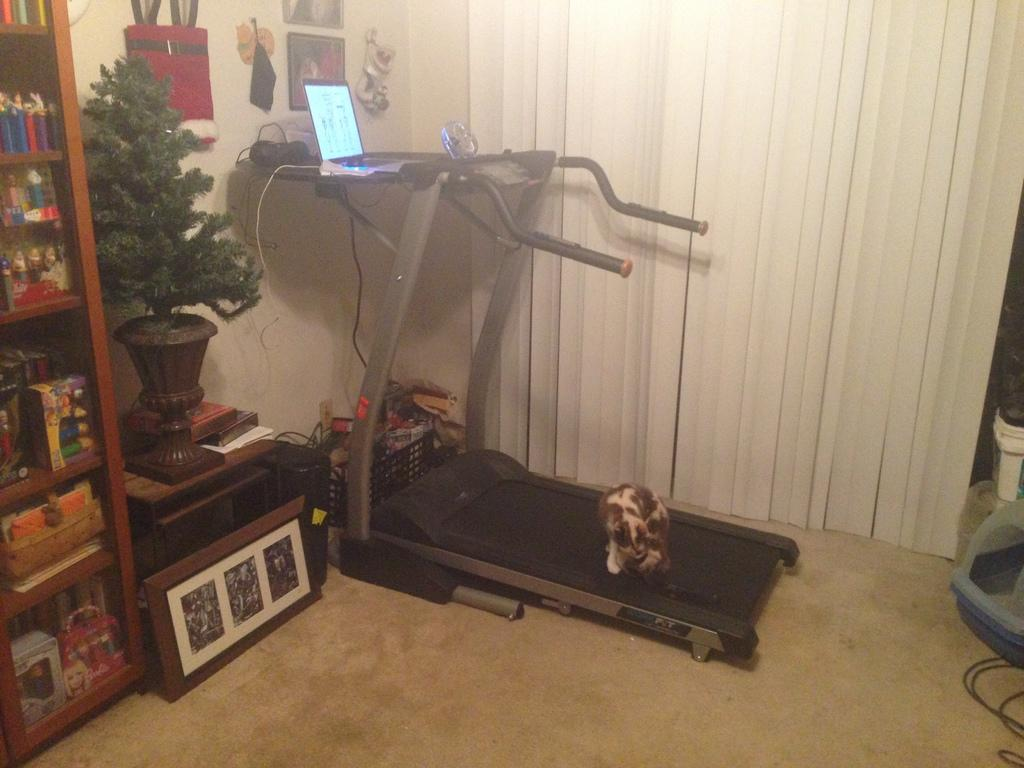What is the dog doing in the image? The dog is on a treadmill in the image. What electronic device is present in the image? There is a laptop in the image. What type of plant can be seen in the image? There is a plant in the image. What object is used for displaying photos in the image? There is a photo frame in the image. What is used for storing items in the image? There is a rack in the image. What type of surface is visible in the image? There is a floor visible in the image. What type of ice can be seen melting on the dog's paw in the image? There is no ice present in the image, and the dog's paws are not shown. 